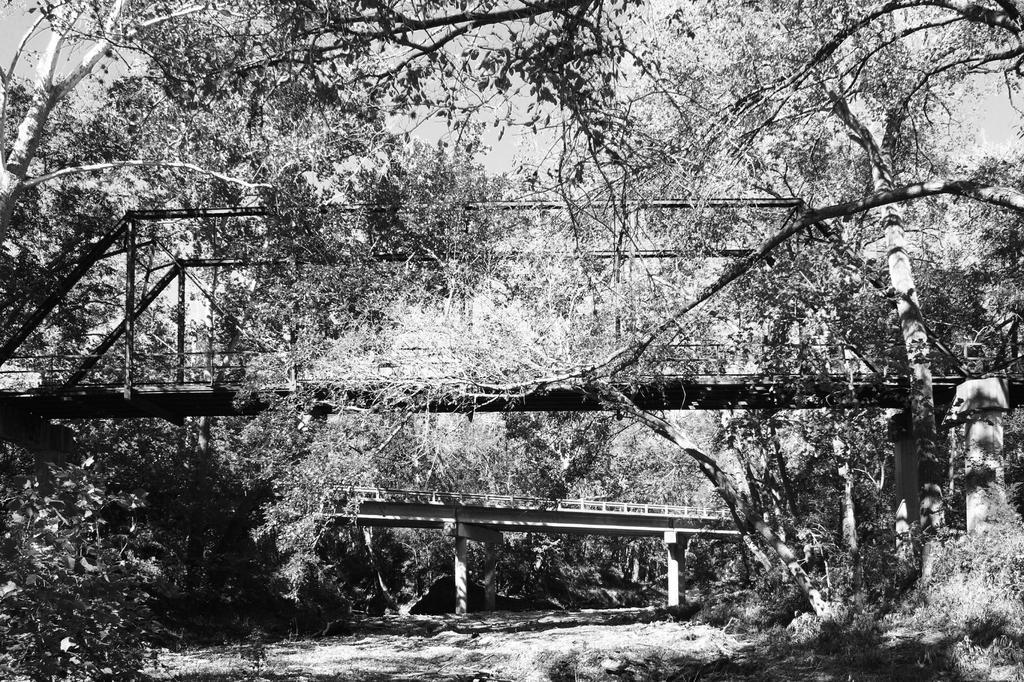In one or two sentences, can you explain what this image depicts? This is a black and white image. In this image we can see bridges, trees. At the bottom of the image there is grass. 